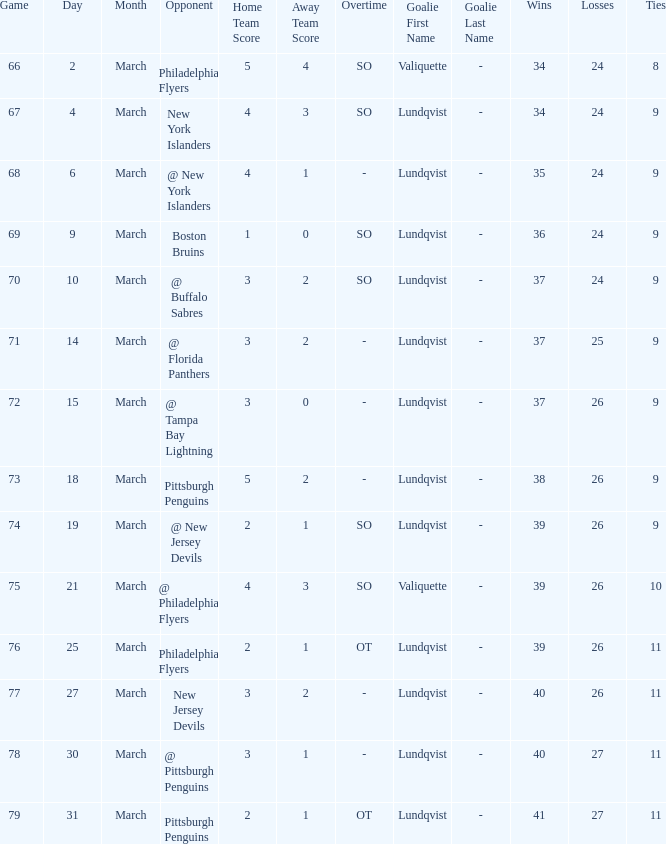Would you mind parsing the complete table? {'header': ['Game', 'Day', 'Month', 'Opponent', 'Home Team Score', 'Away Team Score', 'Overtime', 'Goalie First Name', 'Goalie Last Name', 'Wins', 'Losses', 'Ties'], 'rows': [['66', '2', 'March', 'Philadelphia Flyers', '5', '4', 'SO', 'Valiquette', '-', '34', '24', '8'], ['67', '4', 'March', 'New York Islanders', '4', '3', 'SO', 'Lundqvist', '-', '34', '24', '9'], ['68', '6', 'March', '@ New York Islanders', '4', '1', '-', 'Lundqvist', '-', '35', '24', '9'], ['69', '9', 'March', 'Boston Bruins', '1', '0', 'SO', 'Lundqvist', '-', '36', '24', '9'], ['70', '10', 'March', '@ Buffalo Sabres', '3', '2', 'SO', 'Lundqvist', '-', '37', '24', '9'], ['71', '14', 'March', '@ Florida Panthers', '3', '2', '-', 'Lundqvist', '-', '37', '25', '9'], ['72', '15', 'March', '@ Tampa Bay Lightning', '3', '0', '-', 'Lundqvist', '-', '37', '26', '9'], ['73', '18', 'March', 'Pittsburgh Penguins', '5', '2', '-', 'Lundqvist', '-', '38', '26', '9'], ['74', '19', 'March', '@ New Jersey Devils', '2', '1', 'SO', 'Lundqvist', '-', '39', '26', '9'], ['75', '21', 'March', '@ Philadelphia Flyers', '4', '3', 'SO', 'Valiquette', '-', '39', '26', '10'], ['76', '25', 'March', 'Philadelphia Flyers', '2', '1', 'OT', 'Lundqvist', '-', '39', '26', '11'], ['77', '27', 'March', 'New Jersey Devils', '3', '2', '-', 'Lundqvist', '-', '40', '26', '11'], ['78', '30', 'March', '@ Pittsburgh Penguins', '3', '1', '-', 'Lundqvist', '-', '40', '27', '11'], ['79', '31', 'March', 'Pittsburgh Penguins', '2', '1', 'OT', 'Lundqvist', '-', '41', '27', '11']]} Which opponent's march was 31? Pittsburgh Penguins. 